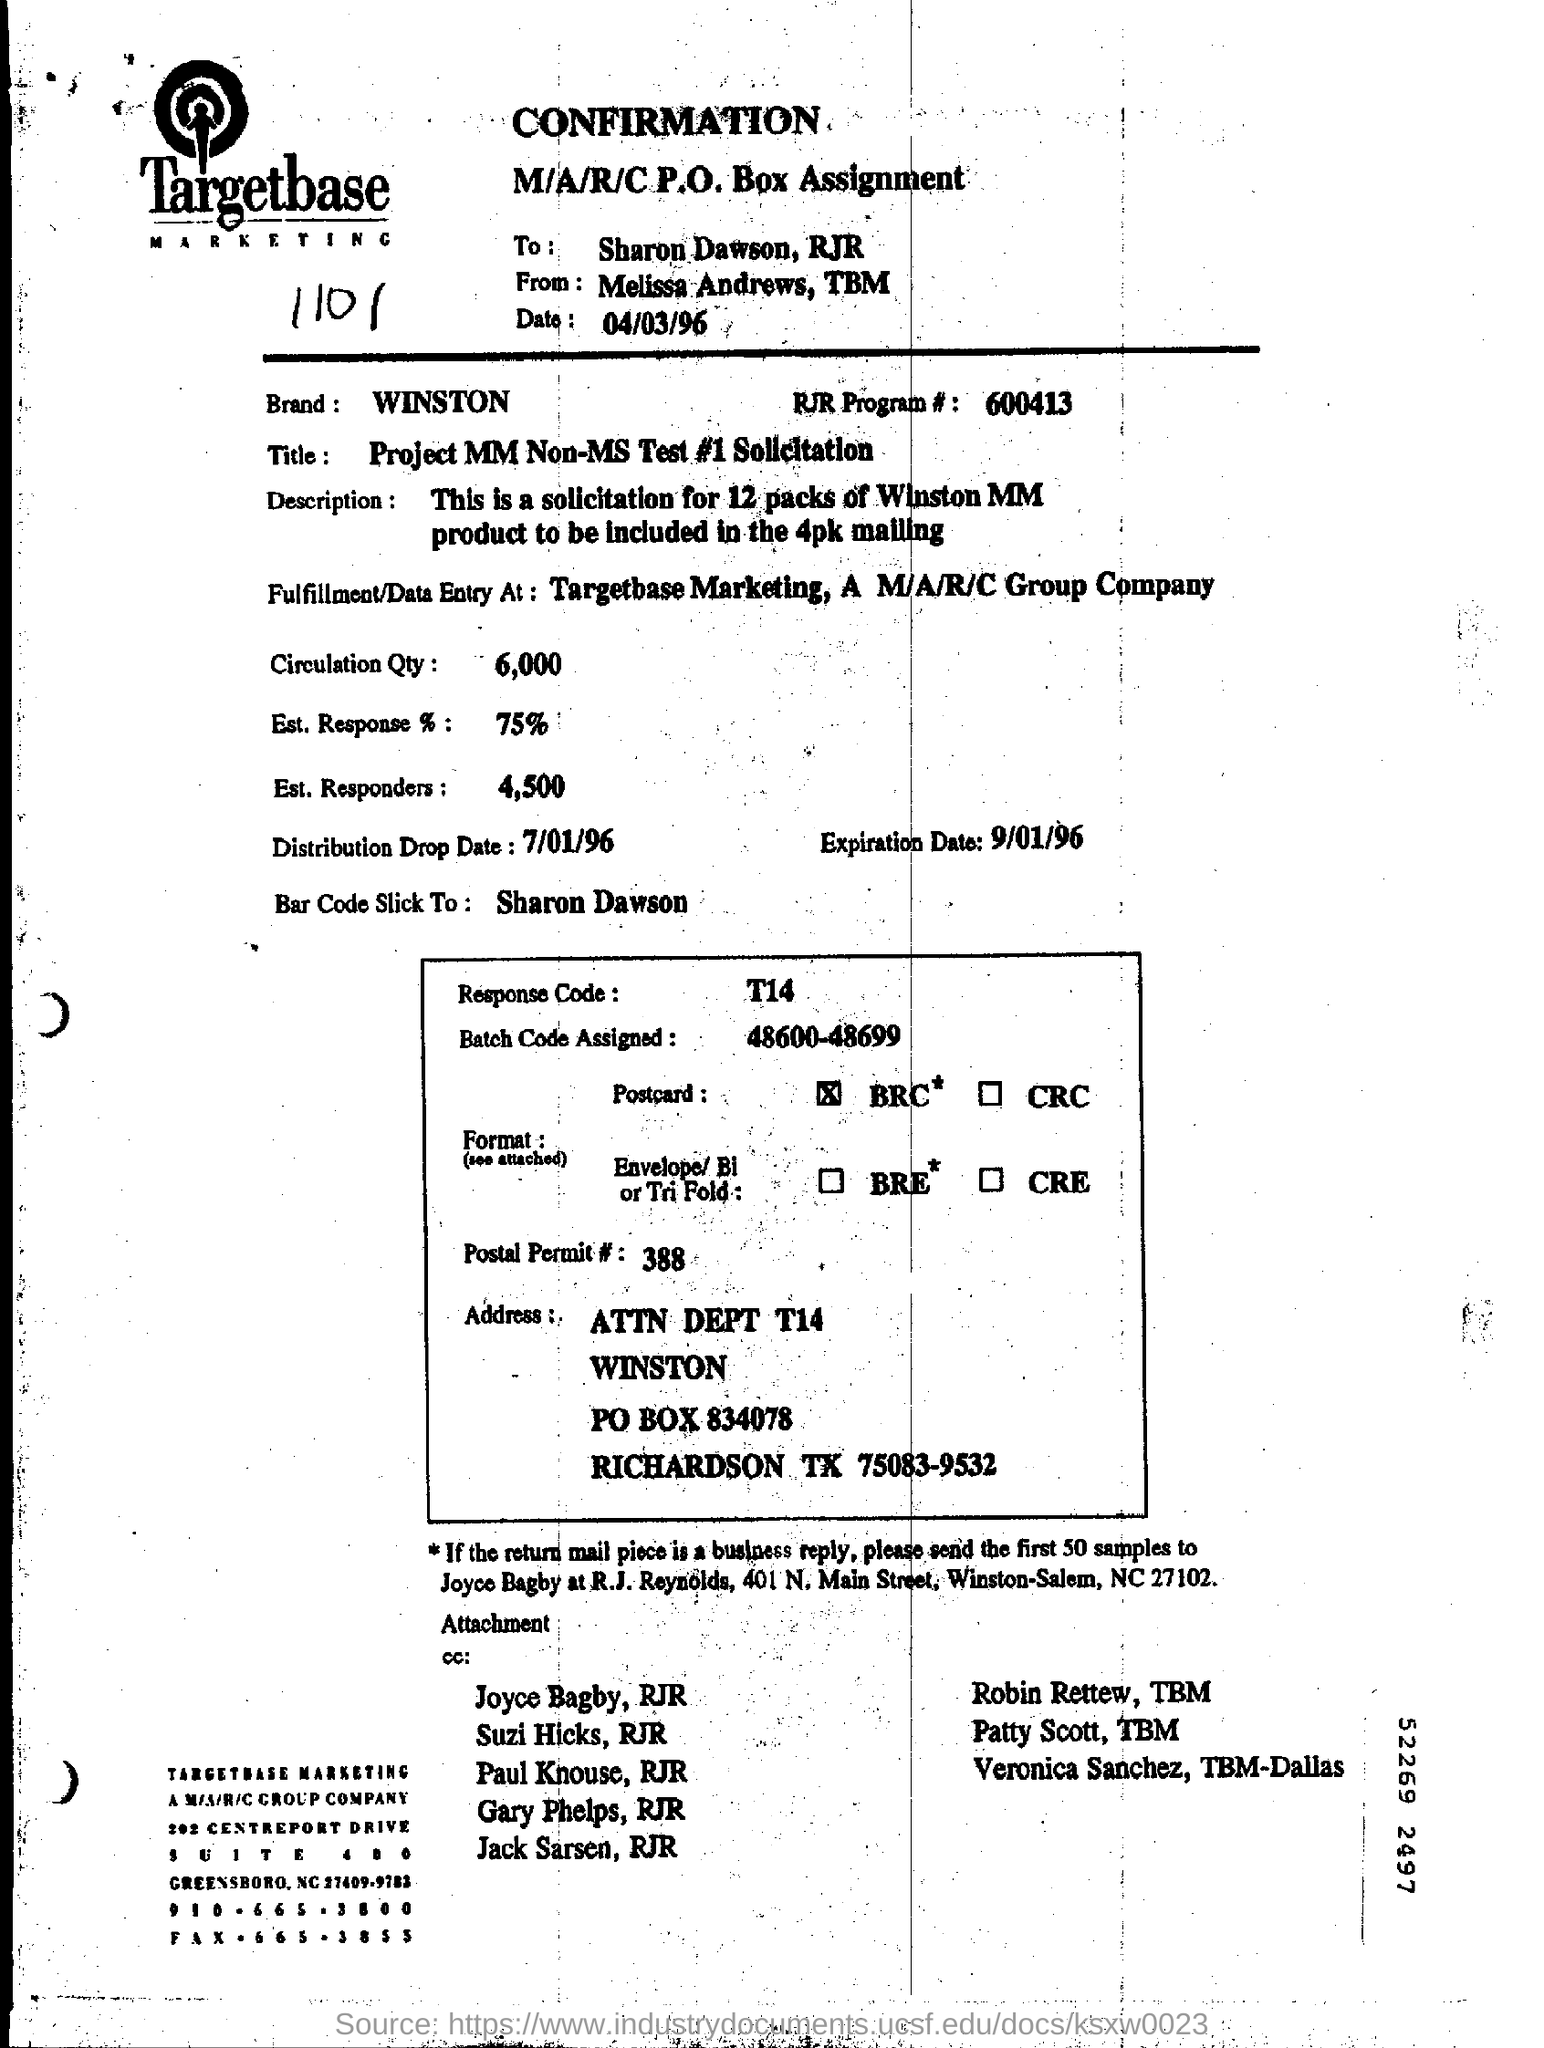To whom is this document addressed?
Your answer should be compact. Sharon Dawson, RJR. By whom is this document written?
Provide a succinct answer. Melissa Andrews, TBM. What is the Distribution Drop Date?
Give a very brief answer. 7/01/96. What is the Response Code mentioned in the box?
Provide a short and direct response. T14. 